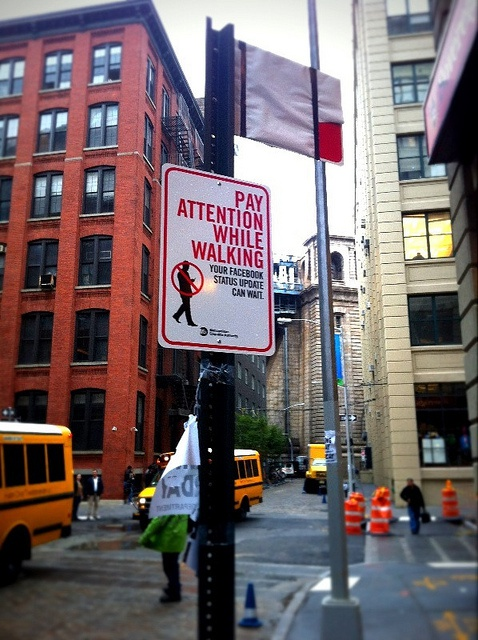Describe the objects in this image and their specific colors. I can see bus in darkgray, black, maroon, and brown tones, people in darkgray, black, darkgreen, and teal tones, bus in darkgray, black, brown, maroon, and red tones, people in darkgray, black, navy, gray, and maroon tones, and truck in darkgray, black, orange, khaki, and ivory tones in this image. 